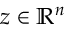Convert formula to latex. <formula><loc_0><loc_0><loc_500><loc_500>z \in \mathbb { R } ^ { n }</formula> 